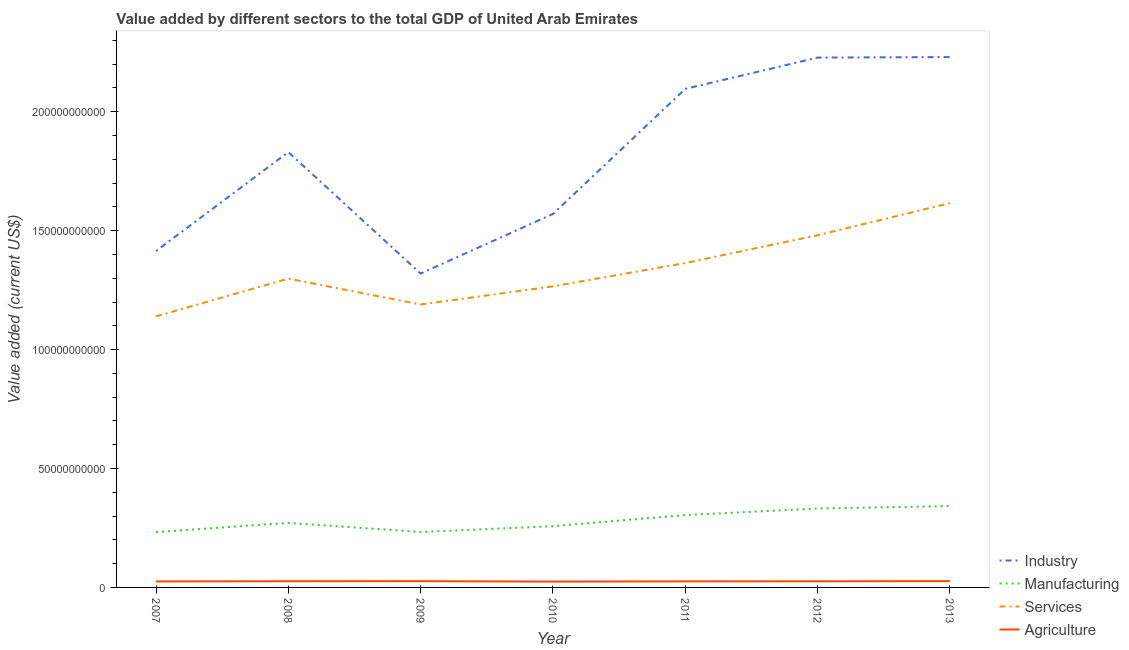Is the number of lines equal to the number of legend labels?
Give a very brief answer. Yes. What is the value added by industrial sector in 2009?
Make the answer very short. 1.32e+11. Across all years, what is the maximum value added by services sector?
Your answer should be compact. 1.62e+11. Across all years, what is the minimum value added by industrial sector?
Give a very brief answer. 1.32e+11. In which year was the value added by services sector maximum?
Ensure brevity in your answer.  2013. In which year was the value added by manufacturing sector minimum?
Your response must be concise. 2007. What is the total value added by services sector in the graph?
Offer a terse response. 9.35e+11. What is the difference between the value added by agricultural sector in 2012 and that in 2013?
Your response must be concise. -6.13e+07. What is the difference between the value added by manufacturing sector in 2009 and the value added by services sector in 2008?
Keep it short and to the point. -1.07e+11. What is the average value added by industrial sector per year?
Keep it short and to the point. 1.81e+11. In the year 2011, what is the difference between the value added by industrial sector and value added by services sector?
Provide a short and direct response. 7.32e+1. In how many years, is the value added by agricultural sector greater than 210000000000 US$?
Your answer should be very brief. 0. What is the ratio of the value added by manufacturing sector in 2010 to that in 2011?
Provide a short and direct response. 0.85. Is the value added by services sector in 2008 less than that in 2010?
Provide a short and direct response. No. Is the difference between the value added by services sector in 2009 and 2011 greater than the difference between the value added by manufacturing sector in 2009 and 2011?
Your answer should be compact. No. What is the difference between the highest and the second highest value added by agricultural sector?
Give a very brief answer. 1.44e+07. What is the difference between the highest and the lowest value added by services sector?
Make the answer very short. 4.76e+1. In how many years, is the value added by services sector greater than the average value added by services sector taken over all years?
Offer a very short reply. 3. Is it the case that in every year, the sum of the value added by industrial sector and value added by manufacturing sector is greater than the sum of value added by services sector and value added by agricultural sector?
Give a very brief answer. Yes. Is it the case that in every year, the sum of the value added by industrial sector and value added by manufacturing sector is greater than the value added by services sector?
Your answer should be compact. Yes. Does the value added by services sector monotonically increase over the years?
Offer a very short reply. No. Is the value added by agricultural sector strictly greater than the value added by services sector over the years?
Offer a very short reply. No. What is the difference between two consecutive major ticks on the Y-axis?
Give a very brief answer. 5.00e+1. Are the values on the major ticks of Y-axis written in scientific E-notation?
Make the answer very short. No. Does the graph contain any zero values?
Offer a very short reply. No. Does the graph contain grids?
Give a very brief answer. No. Where does the legend appear in the graph?
Give a very brief answer. Bottom right. What is the title of the graph?
Make the answer very short. Value added by different sectors to the total GDP of United Arab Emirates. Does "Tertiary schools" appear as one of the legend labels in the graph?
Give a very brief answer. No. What is the label or title of the X-axis?
Ensure brevity in your answer.  Year. What is the label or title of the Y-axis?
Make the answer very short. Value added (current US$). What is the Value added (current US$) of Industry in 2007?
Ensure brevity in your answer.  1.41e+11. What is the Value added (current US$) of Manufacturing in 2007?
Offer a very short reply. 2.33e+1. What is the Value added (current US$) of Services in 2007?
Give a very brief answer. 1.14e+11. What is the Value added (current US$) of Agriculture in 2007?
Provide a succinct answer. 2.52e+09. What is the Value added (current US$) in Industry in 2008?
Your answer should be very brief. 1.83e+11. What is the Value added (current US$) of Manufacturing in 2008?
Provide a succinct answer. 2.71e+1. What is the Value added (current US$) in Services in 2008?
Give a very brief answer. 1.30e+11. What is the Value added (current US$) of Agriculture in 2008?
Provide a succinct answer. 2.61e+09. What is the Value added (current US$) in Industry in 2009?
Keep it short and to the point. 1.32e+11. What is the Value added (current US$) of Manufacturing in 2009?
Provide a short and direct response. 2.33e+1. What is the Value added (current US$) in Services in 2009?
Your answer should be compact. 1.19e+11. What is the Value added (current US$) of Agriculture in 2009?
Give a very brief answer. 2.63e+09. What is the Value added (current US$) in Industry in 2010?
Offer a terse response. 1.57e+11. What is the Value added (current US$) of Manufacturing in 2010?
Offer a terse response. 2.57e+1. What is the Value added (current US$) in Services in 2010?
Your answer should be compact. 1.27e+11. What is the Value added (current US$) of Agriculture in 2010?
Keep it short and to the point. 2.45e+09. What is the Value added (current US$) of Industry in 2011?
Ensure brevity in your answer.  2.10e+11. What is the Value added (current US$) in Manufacturing in 2011?
Offer a very short reply. 3.04e+1. What is the Value added (current US$) in Services in 2011?
Keep it short and to the point. 1.36e+11. What is the Value added (current US$) in Agriculture in 2011?
Ensure brevity in your answer.  2.55e+09. What is the Value added (current US$) in Industry in 2012?
Ensure brevity in your answer.  2.23e+11. What is the Value added (current US$) of Manufacturing in 2012?
Make the answer very short. 3.32e+1. What is the Value added (current US$) in Services in 2012?
Ensure brevity in your answer.  1.48e+11. What is the Value added (current US$) of Agriculture in 2012?
Keep it short and to the point. 2.58e+09. What is the Value added (current US$) in Industry in 2013?
Keep it short and to the point. 2.23e+11. What is the Value added (current US$) of Manufacturing in 2013?
Your answer should be very brief. 3.42e+1. What is the Value added (current US$) of Services in 2013?
Provide a succinct answer. 1.62e+11. What is the Value added (current US$) in Agriculture in 2013?
Ensure brevity in your answer.  2.64e+09. Across all years, what is the maximum Value added (current US$) of Industry?
Provide a succinct answer. 2.23e+11. Across all years, what is the maximum Value added (current US$) in Manufacturing?
Ensure brevity in your answer.  3.42e+1. Across all years, what is the maximum Value added (current US$) in Services?
Give a very brief answer. 1.62e+11. Across all years, what is the maximum Value added (current US$) of Agriculture?
Your answer should be compact. 2.64e+09. Across all years, what is the minimum Value added (current US$) of Industry?
Offer a very short reply. 1.32e+11. Across all years, what is the minimum Value added (current US$) of Manufacturing?
Your answer should be compact. 2.33e+1. Across all years, what is the minimum Value added (current US$) of Services?
Your answer should be very brief. 1.14e+11. Across all years, what is the minimum Value added (current US$) in Agriculture?
Your answer should be very brief. 2.45e+09. What is the total Value added (current US$) in Industry in the graph?
Keep it short and to the point. 1.27e+12. What is the total Value added (current US$) of Manufacturing in the graph?
Provide a succinct answer. 1.97e+11. What is the total Value added (current US$) of Services in the graph?
Offer a very short reply. 9.35e+11. What is the total Value added (current US$) in Agriculture in the graph?
Keep it short and to the point. 1.80e+1. What is the difference between the Value added (current US$) of Industry in 2007 and that in 2008?
Give a very brief answer. -4.16e+1. What is the difference between the Value added (current US$) of Manufacturing in 2007 and that in 2008?
Provide a succinct answer. -3.85e+09. What is the difference between the Value added (current US$) in Services in 2007 and that in 2008?
Keep it short and to the point. -1.59e+1. What is the difference between the Value added (current US$) in Agriculture in 2007 and that in 2008?
Keep it short and to the point. -9.09e+07. What is the difference between the Value added (current US$) of Industry in 2007 and that in 2009?
Make the answer very short. 9.48e+09. What is the difference between the Value added (current US$) of Manufacturing in 2007 and that in 2009?
Give a very brief answer. -3.62e+07. What is the difference between the Value added (current US$) of Services in 2007 and that in 2009?
Give a very brief answer. -5.00e+09. What is the difference between the Value added (current US$) of Agriculture in 2007 and that in 2009?
Ensure brevity in your answer.  -1.10e+08. What is the difference between the Value added (current US$) in Industry in 2007 and that in 2010?
Your answer should be very brief. -1.56e+1. What is the difference between the Value added (current US$) of Manufacturing in 2007 and that in 2010?
Keep it short and to the point. -2.47e+09. What is the difference between the Value added (current US$) of Services in 2007 and that in 2010?
Your response must be concise. -1.26e+1. What is the difference between the Value added (current US$) of Agriculture in 2007 and that in 2010?
Your answer should be compact. 7.05e+07. What is the difference between the Value added (current US$) in Industry in 2007 and that in 2011?
Offer a very short reply. -6.82e+1. What is the difference between the Value added (current US$) of Manufacturing in 2007 and that in 2011?
Offer a terse response. -7.16e+09. What is the difference between the Value added (current US$) in Services in 2007 and that in 2011?
Make the answer very short. -2.24e+1. What is the difference between the Value added (current US$) of Agriculture in 2007 and that in 2011?
Your answer should be very brief. -2.80e+07. What is the difference between the Value added (current US$) in Industry in 2007 and that in 2012?
Offer a very short reply. -8.13e+1. What is the difference between the Value added (current US$) in Manufacturing in 2007 and that in 2012?
Keep it short and to the point. -9.89e+09. What is the difference between the Value added (current US$) of Services in 2007 and that in 2012?
Ensure brevity in your answer.  -3.41e+1. What is the difference between the Value added (current US$) in Agriculture in 2007 and that in 2012?
Offer a terse response. -6.32e+07. What is the difference between the Value added (current US$) of Industry in 2007 and that in 2013?
Give a very brief answer. -8.16e+1. What is the difference between the Value added (current US$) in Manufacturing in 2007 and that in 2013?
Offer a terse response. -1.09e+1. What is the difference between the Value added (current US$) in Services in 2007 and that in 2013?
Provide a succinct answer. -4.76e+1. What is the difference between the Value added (current US$) in Agriculture in 2007 and that in 2013?
Keep it short and to the point. -1.24e+08. What is the difference between the Value added (current US$) in Industry in 2008 and that in 2009?
Your answer should be very brief. 5.11e+1. What is the difference between the Value added (current US$) in Manufacturing in 2008 and that in 2009?
Offer a terse response. 3.82e+09. What is the difference between the Value added (current US$) in Services in 2008 and that in 2009?
Make the answer very short. 1.09e+1. What is the difference between the Value added (current US$) of Agriculture in 2008 and that in 2009?
Offer a very short reply. -1.91e+07. What is the difference between the Value added (current US$) of Industry in 2008 and that in 2010?
Keep it short and to the point. 2.60e+1. What is the difference between the Value added (current US$) in Manufacturing in 2008 and that in 2010?
Provide a succinct answer. 1.39e+09. What is the difference between the Value added (current US$) in Services in 2008 and that in 2010?
Offer a terse response. 3.25e+09. What is the difference between the Value added (current US$) in Agriculture in 2008 and that in 2010?
Your answer should be compact. 1.61e+08. What is the difference between the Value added (current US$) of Industry in 2008 and that in 2011?
Your response must be concise. -2.66e+1. What is the difference between the Value added (current US$) in Manufacturing in 2008 and that in 2011?
Give a very brief answer. -3.30e+09. What is the difference between the Value added (current US$) in Services in 2008 and that in 2011?
Your answer should be very brief. -6.54e+09. What is the difference between the Value added (current US$) of Agriculture in 2008 and that in 2011?
Provide a succinct answer. 6.29e+07. What is the difference between the Value added (current US$) in Industry in 2008 and that in 2012?
Provide a succinct answer. -3.97e+1. What is the difference between the Value added (current US$) in Manufacturing in 2008 and that in 2012?
Offer a terse response. -6.04e+09. What is the difference between the Value added (current US$) of Services in 2008 and that in 2012?
Ensure brevity in your answer.  -1.82e+1. What is the difference between the Value added (current US$) in Agriculture in 2008 and that in 2012?
Provide a short and direct response. 2.78e+07. What is the difference between the Value added (current US$) in Industry in 2008 and that in 2013?
Offer a very short reply. -4.00e+1. What is the difference between the Value added (current US$) in Manufacturing in 2008 and that in 2013?
Provide a short and direct response. -7.08e+09. What is the difference between the Value added (current US$) of Services in 2008 and that in 2013?
Ensure brevity in your answer.  -3.17e+1. What is the difference between the Value added (current US$) of Agriculture in 2008 and that in 2013?
Your response must be concise. -3.35e+07. What is the difference between the Value added (current US$) of Industry in 2009 and that in 2010?
Provide a succinct answer. -2.51e+1. What is the difference between the Value added (current US$) in Manufacturing in 2009 and that in 2010?
Make the answer very short. -2.43e+09. What is the difference between the Value added (current US$) in Services in 2009 and that in 2010?
Offer a terse response. -7.62e+09. What is the difference between the Value added (current US$) in Agriculture in 2009 and that in 2010?
Your answer should be compact. 1.81e+08. What is the difference between the Value added (current US$) in Industry in 2009 and that in 2011?
Give a very brief answer. -7.76e+1. What is the difference between the Value added (current US$) of Manufacturing in 2009 and that in 2011?
Offer a terse response. -7.12e+09. What is the difference between the Value added (current US$) in Services in 2009 and that in 2011?
Offer a very short reply. -1.74e+1. What is the difference between the Value added (current US$) in Agriculture in 2009 and that in 2011?
Make the answer very short. 8.20e+07. What is the difference between the Value added (current US$) of Industry in 2009 and that in 2012?
Offer a terse response. -9.08e+1. What is the difference between the Value added (current US$) in Manufacturing in 2009 and that in 2012?
Provide a succinct answer. -9.86e+09. What is the difference between the Value added (current US$) of Services in 2009 and that in 2012?
Provide a short and direct response. -2.91e+1. What is the difference between the Value added (current US$) of Agriculture in 2009 and that in 2012?
Offer a terse response. 4.68e+07. What is the difference between the Value added (current US$) of Industry in 2009 and that in 2013?
Your answer should be very brief. -9.10e+1. What is the difference between the Value added (current US$) in Manufacturing in 2009 and that in 2013?
Provide a short and direct response. -1.09e+1. What is the difference between the Value added (current US$) in Services in 2009 and that in 2013?
Keep it short and to the point. -4.26e+1. What is the difference between the Value added (current US$) in Agriculture in 2009 and that in 2013?
Offer a very short reply. -1.44e+07. What is the difference between the Value added (current US$) in Industry in 2010 and that in 2011?
Offer a very short reply. -5.26e+1. What is the difference between the Value added (current US$) in Manufacturing in 2010 and that in 2011?
Your answer should be very brief. -4.69e+09. What is the difference between the Value added (current US$) of Services in 2010 and that in 2011?
Offer a very short reply. -9.79e+09. What is the difference between the Value added (current US$) in Agriculture in 2010 and that in 2011?
Offer a very short reply. -9.86e+07. What is the difference between the Value added (current US$) of Industry in 2010 and that in 2012?
Your answer should be very brief. -6.57e+1. What is the difference between the Value added (current US$) of Manufacturing in 2010 and that in 2012?
Provide a succinct answer. -7.43e+09. What is the difference between the Value added (current US$) in Services in 2010 and that in 2012?
Make the answer very short. -2.15e+1. What is the difference between the Value added (current US$) of Agriculture in 2010 and that in 2012?
Make the answer very short. -1.34e+08. What is the difference between the Value added (current US$) of Industry in 2010 and that in 2013?
Your answer should be compact. -6.60e+1. What is the difference between the Value added (current US$) of Manufacturing in 2010 and that in 2013?
Offer a very short reply. -8.46e+09. What is the difference between the Value added (current US$) in Services in 2010 and that in 2013?
Provide a short and direct response. -3.50e+1. What is the difference between the Value added (current US$) in Agriculture in 2010 and that in 2013?
Provide a succinct answer. -1.95e+08. What is the difference between the Value added (current US$) in Industry in 2011 and that in 2012?
Provide a succinct answer. -1.32e+1. What is the difference between the Value added (current US$) of Manufacturing in 2011 and that in 2012?
Your answer should be compact. -2.73e+09. What is the difference between the Value added (current US$) of Services in 2011 and that in 2012?
Your answer should be compact. -1.17e+1. What is the difference between the Value added (current US$) of Agriculture in 2011 and that in 2012?
Offer a terse response. -3.51e+07. What is the difference between the Value added (current US$) in Industry in 2011 and that in 2013?
Your answer should be compact. -1.34e+1. What is the difference between the Value added (current US$) of Manufacturing in 2011 and that in 2013?
Ensure brevity in your answer.  -3.77e+09. What is the difference between the Value added (current US$) in Services in 2011 and that in 2013?
Offer a terse response. -2.52e+1. What is the difference between the Value added (current US$) of Agriculture in 2011 and that in 2013?
Provide a succinct answer. -9.64e+07. What is the difference between the Value added (current US$) of Industry in 2012 and that in 2013?
Provide a succinct answer. -2.27e+08. What is the difference between the Value added (current US$) in Manufacturing in 2012 and that in 2013?
Your response must be concise. -1.04e+09. What is the difference between the Value added (current US$) of Services in 2012 and that in 2013?
Ensure brevity in your answer.  -1.35e+1. What is the difference between the Value added (current US$) of Agriculture in 2012 and that in 2013?
Keep it short and to the point. -6.13e+07. What is the difference between the Value added (current US$) in Industry in 2007 and the Value added (current US$) in Manufacturing in 2008?
Offer a very short reply. 1.14e+11. What is the difference between the Value added (current US$) in Industry in 2007 and the Value added (current US$) in Services in 2008?
Your response must be concise. 1.16e+1. What is the difference between the Value added (current US$) in Industry in 2007 and the Value added (current US$) in Agriculture in 2008?
Provide a short and direct response. 1.39e+11. What is the difference between the Value added (current US$) of Manufacturing in 2007 and the Value added (current US$) of Services in 2008?
Keep it short and to the point. -1.07e+11. What is the difference between the Value added (current US$) in Manufacturing in 2007 and the Value added (current US$) in Agriculture in 2008?
Your answer should be compact. 2.07e+1. What is the difference between the Value added (current US$) of Services in 2007 and the Value added (current US$) of Agriculture in 2008?
Keep it short and to the point. 1.11e+11. What is the difference between the Value added (current US$) of Industry in 2007 and the Value added (current US$) of Manufacturing in 2009?
Ensure brevity in your answer.  1.18e+11. What is the difference between the Value added (current US$) in Industry in 2007 and the Value added (current US$) in Services in 2009?
Provide a succinct answer. 2.25e+1. What is the difference between the Value added (current US$) in Industry in 2007 and the Value added (current US$) in Agriculture in 2009?
Make the answer very short. 1.39e+11. What is the difference between the Value added (current US$) in Manufacturing in 2007 and the Value added (current US$) in Services in 2009?
Offer a very short reply. -9.57e+1. What is the difference between the Value added (current US$) in Manufacturing in 2007 and the Value added (current US$) in Agriculture in 2009?
Your response must be concise. 2.06e+1. What is the difference between the Value added (current US$) in Services in 2007 and the Value added (current US$) in Agriculture in 2009?
Provide a succinct answer. 1.11e+11. What is the difference between the Value added (current US$) of Industry in 2007 and the Value added (current US$) of Manufacturing in 2010?
Your answer should be compact. 1.16e+11. What is the difference between the Value added (current US$) of Industry in 2007 and the Value added (current US$) of Services in 2010?
Keep it short and to the point. 1.49e+1. What is the difference between the Value added (current US$) of Industry in 2007 and the Value added (current US$) of Agriculture in 2010?
Make the answer very short. 1.39e+11. What is the difference between the Value added (current US$) of Manufacturing in 2007 and the Value added (current US$) of Services in 2010?
Keep it short and to the point. -1.03e+11. What is the difference between the Value added (current US$) in Manufacturing in 2007 and the Value added (current US$) in Agriculture in 2010?
Offer a terse response. 2.08e+1. What is the difference between the Value added (current US$) in Services in 2007 and the Value added (current US$) in Agriculture in 2010?
Keep it short and to the point. 1.12e+11. What is the difference between the Value added (current US$) in Industry in 2007 and the Value added (current US$) in Manufacturing in 2011?
Keep it short and to the point. 1.11e+11. What is the difference between the Value added (current US$) in Industry in 2007 and the Value added (current US$) in Services in 2011?
Make the answer very short. 5.06e+09. What is the difference between the Value added (current US$) in Industry in 2007 and the Value added (current US$) in Agriculture in 2011?
Offer a terse response. 1.39e+11. What is the difference between the Value added (current US$) in Manufacturing in 2007 and the Value added (current US$) in Services in 2011?
Your answer should be very brief. -1.13e+11. What is the difference between the Value added (current US$) in Manufacturing in 2007 and the Value added (current US$) in Agriculture in 2011?
Offer a very short reply. 2.07e+1. What is the difference between the Value added (current US$) of Services in 2007 and the Value added (current US$) of Agriculture in 2011?
Give a very brief answer. 1.11e+11. What is the difference between the Value added (current US$) of Industry in 2007 and the Value added (current US$) of Manufacturing in 2012?
Give a very brief answer. 1.08e+11. What is the difference between the Value added (current US$) in Industry in 2007 and the Value added (current US$) in Services in 2012?
Offer a terse response. -6.64e+09. What is the difference between the Value added (current US$) in Industry in 2007 and the Value added (current US$) in Agriculture in 2012?
Make the answer very short. 1.39e+11. What is the difference between the Value added (current US$) of Manufacturing in 2007 and the Value added (current US$) of Services in 2012?
Offer a very short reply. -1.25e+11. What is the difference between the Value added (current US$) of Manufacturing in 2007 and the Value added (current US$) of Agriculture in 2012?
Offer a terse response. 2.07e+1. What is the difference between the Value added (current US$) in Services in 2007 and the Value added (current US$) in Agriculture in 2012?
Offer a terse response. 1.11e+11. What is the difference between the Value added (current US$) of Industry in 2007 and the Value added (current US$) of Manufacturing in 2013?
Your response must be concise. 1.07e+11. What is the difference between the Value added (current US$) in Industry in 2007 and the Value added (current US$) in Services in 2013?
Your response must be concise. -2.01e+1. What is the difference between the Value added (current US$) of Industry in 2007 and the Value added (current US$) of Agriculture in 2013?
Ensure brevity in your answer.  1.39e+11. What is the difference between the Value added (current US$) in Manufacturing in 2007 and the Value added (current US$) in Services in 2013?
Your answer should be compact. -1.38e+11. What is the difference between the Value added (current US$) in Manufacturing in 2007 and the Value added (current US$) in Agriculture in 2013?
Offer a very short reply. 2.06e+1. What is the difference between the Value added (current US$) of Services in 2007 and the Value added (current US$) of Agriculture in 2013?
Offer a terse response. 1.11e+11. What is the difference between the Value added (current US$) in Industry in 2008 and the Value added (current US$) in Manufacturing in 2009?
Offer a very short reply. 1.60e+11. What is the difference between the Value added (current US$) of Industry in 2008 and the Value added (current US$) of Services in 2009?
Your response must be concise. 6.41e+1. What is the difference between the Value added (current US$) of Industry in 2008 and the Value added (current US$) of Agriculture in 2009?
Make the answer very short. 1.80e+11. What is the difference between the Value added (current US$) in Manufacturing in 2008 and the Value added (current US$) in Services in 2009?
Provide a short and direct response. -9.18e+1. What is the difference between the Value added (current US$) in Manufacturing in 2008 and the Value added (current US$) in Agriculture in 2009?
Provide a short and direct response. 2.45e+1. What is the difference between the Value added (current US$) of Services in 2008 and the Value added (current US$) of Agriculture in 2009?
Your answer should be very brief. 1.27e+11. What is the difference between the Value added (current US$) of Industry in 2008 and the Value added (current US$) of Manufacturing in 2010?
Make the answer very short. 1.57e+11. What is the difference between the Value added (current US$) in Industry in 2008 and the Value added (current US$) in Services in 2010?
Your response must be concise. 5.64e+1. What is the difference between the Value added (current US$) in Industry in 2008 and the Value added (current US$) in Agriculture in 2010?
Give a very brief answer. 1.81e+11. What is the difference between the Value added (current US$) in Manufacturing in 2008 and the Value added (current US$) in Services in 2010?
Keep it short and to the point. -9.95e+1. What is the difference between the Value added (current US$) in Manufacturing in 2008 and the Value added (current US$) in Agriculture in 2010?
Make the answer very short. 2.47e+1. What is the difference between the Value added (current US$) in Services in 2008 and the Value added (current US$) in Agriculture in 2010?
Keep it short and to the point. 1.27e+11. What is the difference between the Value added (current US$) in Industry in 2008 and the Value added (current US$) in Manufacturing in 2011?
Provide a short and direct response. 1.53e+11. What is the difference between the Value added (current US$) in Industry in 2008 and the Value added (current US$) in Services in 2011?
Provide a short and direct response. 4.67e+1. What is the difference between the Value added (current US$) in Industry in 2008 and the Value added (current US$) in Agriculture in 2011?
Make the answer very short. 1.80e+11. What is the difference between the Value added (current US$) in Manufacturing in 2008 and the Value added (current US$) in Services in 2011?
Offer a very short reply. -1.09e+11. What is the difference between the Value added (current US$) of Manufacturing in 2008 and the Value added (current US$) of Agriculture in 2011?
Make the answer very short. 2.46e+1. What is the difference between the Value added (current US$) of Services in 2008 and the Value added (current US$) of Agriculture in 2011?
Provide a succinct answer. 1.27e+11. What is the difference between the Value added (current US$) of Industry in 2008 and the Value added (current US$) of Manufacturing in 2012?
Your answer should be very brief. 1.50e+11. What is the difference between the Value added (current US$) in Industry in 2008 and the Value added (current US$) in Services in 2012?
Offer a very short reply. 3.50e+1. What is the difference between the Value added (current US$) in Industry in 2008 and the Value added (current US$) in Agriculture in 2012?
Your answer should be very brief. 1.80e+11. What is the difference between the Value added (current US$) of Manufacturing in 2008 and the Value added (current US$) of Services in 2012?
Your response must be concise. -1.21e+11. What is the difference between the Value added (current US$) of Manufacturing in 2008 and the Value added (current US$) of Agriculture in 2012?
Ensure brevity in your answer.  2.45e+1. What is the difference between the Value added (current US$) in Services in 2008 and the Value added (current US$) in Agriculture in 2012?
Keep it short and to the point. 1.27e+11. What is the difference between the Value added (current US$) in Industry in 2008 and the Value added (current US$) in Manufacturing in 2013?
Provide a succinct answer. 1.49e+11. What is the difference between the Value added (current US$) in Industry in 2008 and the Value added (current US$) in Services in 2013?
Your response must be concise. 2.15e+1. What is the difference between the Value added (current US$) of Industry in 2008 and the Value added (current US$) of Agriculture in 2013?
Keep it short and to the point. 1.80e+11. What is the difference between the Value added (current US$) in Manufacturing in 2008 and the Value added (current US$) in Services in 2013?
Your answer should be compact. -1.34e+11. What is the difference between the Value added (current US$) in Manufacturing in 2008 and the Value added (current US$) in Agriculture in 2013?
Your response must be concise. 2.45e+1. What is the difference between the Value added (current US$) of Services in 2008 and the Value added (current US$) of Agriculture in 2013?
Provide a succinct answer. 1.27e+11. What is the difference between the Value added (current US$) of Industry in 2009 and the Value added (current US$) of Manufacturing in 2010?
Your answer should be very brief. 1.06e+11. What is the difference between the Value added (current US$) in Industry in 2009 and the Value added (current US$) in Services in 2010?
Keep it short and to the point. 5.38e+09. What is the difference between the Value added (current US$) of Industry in 2009 and the Value added (current US$) of Agriculture in 2010?
Keep it short and to the point. 1.30e+11. What is the difference between the Value added (current US$) in Manufacturing in 2009 and the Value added (current US$) in Services in 2010?
Make the answer very short. -1.03e+11. What is the difference between the Value added (current US$) of Manufacturing in 2009 and the Value added (current US$) of Agriculture in 2010?
Give a very brief answer. 2.09e+1. What is the difference between the Value added (current US$) of Services in 2009 and the Value added (current US$) of Agriculture in 2010?
Give a very brief answer. 1.17e+11. What is the difference between the Value added (current US$) in Industry in 2009 and the Value added (current US$) in Manufacturing in 2011?
Provide a short and direct response. 1.02e+11. What is the difference between the Value added (current US$) in Industry in 2009 and the Value added (current US$) in Services in 2011?
Offer a terse response. -4.42e+09. What is the difference between the Value added (current US$) in Industry in 2009 and the Value added (current US$) in Agriculture in 2011?
Ensure brevity in your answer.  1.29e+11. What is the difference between the Value added (current US$) of Manufacturing in 2009 and the Value added (current US$) of Services in 2011?
Keep it short and to the point. -1.13e+11. What is the difference between the Value added (current US$) of Manufacturing in 2009 and the Value added (current US$) of Agriculture in 2011?
Your answer should be compact. 2.08e+1. What is the difference between the Value added (current US$) of Services in 2009 and the Value added (current US$) of Agriculture in 2011?
Your response must be concise. 1.16e+11. What is the difference between the Value added (current US$) of Industry in 2009 and the Value added (current US$) of Manufacturing in 2012?
Your answer should be very brief. 9.88e+1. What is the difference between the Value added (current US$) of Industry in 2009 and the Value added (current US$) of Services in 2012?
Offer a terse response. -1.61e+1. What is the difference between the Value added (current US$) in Industry in 2009 and the Value added (current US$) in Agriculture in 2012?
Offer a very short reply. 1.29e+11. What is the difference between the Value added (current US$) of Manufacturing in 2009 and the Value added (current US$) of Services in 2012?
Ensure brevity in your answer.  -1.25e+11. What is the difference between the Value added (current US$) in Manufacturing in 2009 and the Value added (current US$) in Agriculture in 2012?
Offer a very short reply. 2.07e+1. What is the difference between the Value added (current US$) in Services in 2009 and the Value added (current US$) in Agriculture in 2012?
Your answer should be very brief. 1.16e+11. What is the difference between the Value added (current US$) in Industry in 2009 and the Value added (current US$) in Manufacturing in 2013?
Keep it short and to the point. 9.78e+1. What is the difference between the Value added (current US$) in Industry in 2009 and the Value added (current US$) in Services in 2013?
Your response must be concise. -2.96e+1. What is the difference between the Value added (current US$) in Industry in 2009 and the Value added (current US$) in Agriculture in 2013?
Offer a terse response. 1.29e+11. What is the difference between the Value added (current US$) in Manufacturing in 2009 and the Value added (current US$) in Services in 2013?
Keep it short and to the point. -1.38e+11. What is the difference between the Value added (current US$) in Manufacturing in 2009 and the Value added (current US$) in Agriculture in 2013?
Provide a short and direct response. 2.07e+1. What is the difference between the Value added (current US$) of Services in 2009 and the Value added (current US$) of Agriculture in 2013?
Your response must be concise. 1.16e+11. What is the difference between the Value added (current US$) in Industry in 2010 and the Value added (current US$) in Manufacturing in 2011?
Provide a succinct answer. 1.27e+11. What is the difference between the Value added (current US$) of Industry in 2010 and the Value added (current US$) of Services in 2011?
Offer a very short reply. 2.06e+1. What is the difference between the Value added (current US$) of Industry in 2010 and the Value added (current US$) of Agriculture in 2011?
Make the answer very short. 1.54e+11. What is the difference between the Value added (current US$) in Manufacturing in 2010 and the Value added (current US$) in Services in 2011?
Offer a very short reply. -1.11e+11. What is the difference between the Value added (current US$) in Manufacturing in 2010 and the Value added (current US$) in Agriculture in 2011?
Offer a terse response. 2.32e+1. What is the difference between the Value added (current US$) in Services in 2010 and the Value added (current US$) in Agriculture in 2011?
Offer a very short reply. 1.24e+11. What is the difference between the Value added (current US$) of Industry in 2010 and the Value added (current US$) of Manufacturing in 2012?
Provide a succinct answer. 1.24e+11. What is the difference between the Value added (current US$) of Industry in 2010 and the Value added (current US$) of Services in 2012?
Your answer should be compact. 8.94e+09. What is the difference between the Value added (current US$) in Industry in 2010 and the Value added (current US$) in Agriculture in 2012?
Make the answer very short. 1.54e+11. What is the difference between the Value added (current US$) in Manufacturing in 2010 and the Value added (current US$) in Services in 2012?
Your answer should be very brief. -1.22e+11. What is the difference between the Value added (current US$) in Manufacturing in 2010 and the Value added (current US$) in Agriculture in 2012?
Your response must be concise. 2.32e+1. What is the difference between the Value added (current US$) in Services in 2010 and the Value added (current US$) in Agriculture in 2012?
Offer a terse response. 1.24e+11. What is the difference between the Value added (current US$) in Industry in 2010 and the Value added (current US$) in Manufacturing in 2013?
Your answer should be very brief. 1.23e+11. What is the difference between the Value added (current US$) of Industry in 2010 and the Value added (current US$) of Services in 2013?
Offer a terse response. -4.54e+09. What is the difference between the Value added (current US$) of Industry in 2010 and the Value added (current US$) of Agriculture in 2013?
Offer a very short reply. 1.54e+11. What is the difference between the Value added (current US$) in Manufacturing in 2010 and the Value added (current US$) in Services in 2013?
Give a very brief answer. -1.36e+11. What is the difference between the Value added (current US$) of Manufacturing in 2010 and the Value added (current US$) of Agriculture in 2013?
Offer a very short reply. 2.31e+1. What is the difference between the Value added (current US$) in Services in 2010 and the Value added (current US$) in Agriculture in 2013?
Your answer should be compact. 1.24e+11. What is the difference between the Value added (current US$) in Industry in 2011 and the Value added (current US$) in Manufacturing in 2012?
Provide a succinct answer. 1.76e+11. What is the difference between the Value added (current US$) of Industry in 2011 and the Value added (current US$) of Services in 2012?
Your answer should be compact. 6.15e+1. What is the difference between the Value added (current US$) of Industry in 2011 and the Value added (current US$) of Agriculture in 2012?
Your answer should be compact. 2.07e+11. What is the difference between the Value added (current US$) of Manufacturing in 2011 and the Value added (current US$) of Services in 2012?
Give a very brief answer. -1.18e+11. What is the difference between the Value added (current US$) of Manufacturing in 2011 and the Value added (current US$) of Agriculture in 2012?
Ensure brevity in your answer.  2.79e+1. What is the difference between the Value added (current US$) in Services in 2011 and the Value added (current US$) in Agriculture in 2012?
Offer a terse response. 1.34e+11. What is the difference between the Value added (current US$) of Industry in 2011 and the Value added (current US$) of Manufacturing in 2013?
Offer a terse response. 1.75e+11. What is the difference between the Value added (current US$) in Industry in 2011 and the Value added (current US$) in Services in 2013?
Offer a terse response. 4.80e+1. What is the difference between the Value added (current US$) of Industry in 2011 and the Value added (current US$) of Agriculture in 2013?
Offer a terse response. 2.07e+11. What is the difference between the Value added (current US$) in Manufacturing in 2011 and the Value added (current US$) in Services in 2013?
Offer a terse response. -1.31e+11. What is the difference between the Value added (current US$) in Manufacturing in 2011 and the Value added (current US$) in Agriculture in 2013?
Make the answer very short. 2.78e+1. What is the difference between the Value added (current US$) of Services in 2011 and the Value added (current US$) of Agriculture in 2013?
Your answer should be very brief. 1.34e+11. What is the difference between the Value added (current US$) in Industry in 2012 and the Value added (current US$) in Manufacturing in 2013?
Your answer should be compact. 1.89e+11. What is the difference between the Value added (current US$) of Industry in 2012 and the Value added (current US$) of Services in 2013?
Ensure brevity in your answer.  6.12e+1. What is the difference between the Value added (current US$) in Industry in 2012 and the Value added (current US$) in Agriculture in 2013?
Give a very brief answer. 2.20e+11. What is the difference between the Value added (current US$) of Manufacturing in 2012 and the Value added (current US$) of Services in 2013?
Give a very brief answer. -1.28e+11. What is the difference between the Value added (current US$) of Manufacturing in 2012 and the Value added (current US$) of Agriculture in 2013?
Ensure brevity in your answer.  3.05e+1. What is the difference between the Value added (current US$) in Services in 2012 and the Value added (current US$) in Agriculture in 2013?
Your answer should be very brief. 1.45e+11. What is the average Value added (current US$) in Industry per year?
Provide a succinct answer. 1.81e+11. What is the average Value added (current US$) in Manufacturing per year?
Give a very brief answer. 2.82e+1. What is the average Value added (current US$) in Services per year?
Offer a terse response. 1.34e+11. What is the average Value added (current US$) in Agriculture per year?
Provide a succinct answer. 2.57e+09. In the year 2007, what is the difference between the Value added (current US$) in Industry and Value added (current US$) in Manufacturing?
Give a very brief answer. 1.18e+11. In the year 2007, what is the difference between the Value added (current US$) in Industry and Value added (current US$) in Services?
Your answer should be very brief. 2.75e+1. In the year 2007, what is the difference between the Value added (current US$) of Industry and Value added (current US$) of Agriculture?
Provide a succinct answer. 1.39e+11. In the year 2007, what is the difference between the Value added (current US$) of Manufacturing and Value added (current US$) of Services?
Offer a very short reply. -9.07e+1. In the year 2007, what is the difference between the Value added (current US$) of Manufacturing and Value added (current US$) of Agriculture?
Provide a succinct answer. 2.08e+1. In the year 2007, what is the difference between the Value added (current US$) in Services and Value added (current US$) in Agriculture?
Your answer should be very brief. 1.11e+11. In the year 2008, what is the difference between the Value added (current US$) of Industry and Value added (current US$) of Manufacturing?
Your answer should be compact. 1.56e+11. In the year 2008, what is the difference between the Value added (current US$) of Industry and Value added (current US$) of Services?
Ensure brevity in your answer.  5.32e+1. In the year 2008, what is the difference between the Value added (current US$) in Industry and Value added (current US$) in Agriculture?
Provide a succinct answer. 1.80e+11. In the year 2008, what is the difference between the Value added (current US$) in Manufacturing and Value added (current US$) in Services?
Make the answer very short. -1.03e+11. In the year 2008, what is the difference between the Value added (current US$) of Manufacturing and Value added (current US$) of Agriculture?
Provide a short and direct response. 2.45e+1. In the year 2008, what is the difference between the Value added (current US$) of Services and Value added (current US$) of Agriculture?
Your answer should be very brief. 1.27e+11. In the year 2009, what is the difference between the Value added (current US$) in Industry and Value added (current US$) in Manufacturing?
Provide a short and direct response. 1.09e+11. In the year 2009, what is the difference between the Value added (current US$) of Industry and Value added (current US$) of Services?
Give a very brief answer. 1.30e+1. In the year 2009, what is the difference between the Value added (current US$) of Industry and Value added (current US$) of Agriculture?
Ensure brevity in your answer.  1.29e+11. In the year 2009, what is the difference between the Value added (current US$) of Manufacturing and Value added (current US$) of Services?
Your response must be concise. -9.56e+1. In the year 2009, what is the difference between the Value added (current US$) of Manufacturing and Value added (current US$) of Agriculture?
Offer a terse response. 2.07e+1. In the year 2009, what is the difference between the Value added (current US$) of Services and Value added (current US$) of Agriculture?
Your response must be concise. 1.16e+11. In the year 2010, what is the difference between the Value added (current US$) of Industry and Value added (current US$) of Manufacturing?
Offer a very short reply. 1.31e+11. In the year 2010, what is the difference between the Value added (current US$) of Industry and Value added (current US$) of Services?
Make the answer very short. 3.04e+1. In the year 2010, what is the difference between the Value added (current US$) in Industry and Value added (current US$) in Agriculture?
Give a very brief answer. 1.55e+11. In the year 2010, what is the difference between the Value added (current US$) of Manufacturing and Value added (current US$) of Services?
Provide a short and direct response. -1.01e+11. In the year 2010, what is the difference between the Value added (current US$) in Manufacturing and Value added (current US$) in Agriculture?
Give a very brief answer. 2.33e+1. In the year 2010, what is the difference between the Value added (current US$) of Services and Value added (current US$) of Agriculture?
Your response must be concise. 1.24e+11. In the year 2011, what is the difference between the Value added (current US$) of Industry and Value added (current US$) of Manufacturing?
Make the answer very short. 1.79e+11. In the year 2011, what is the difference between the Value added (current US$) in Industry and Value added (current US$) in Services?
Ensure brevity in your answer.  7.32e+1. In the year 2011, what is the difference between the Value added (current US$) of Industry and Value added (current US$) of Agriculture?
Offer a very short reply. 2.07e+11. In the year 2011, what is the difference between the Value added (current US$) of Manufacturing and Value added (current US$) of Services?
Provide a succinct answer. -1.06e+11. In the year 2011, what is the difference between the Value added (current US$) of Manufacturing and Value added (current US$) of Agriculture?
Make the answer very short. 2.79e+1. In the year 2011, what is the difference between the Value added (current US$) of Services and Value added (current US$) of Agriculture?
Your answer should be very brief. 1.34e+11. In the year 2012, what is the difference between the Value added (current US$) of Industry and Value added (current US$) of Manufacturing?
Your answer should be very brief. 1.90e+11. In the year 2012, what is the difference between the Value added (current US$) in Industry and Value added (current US$) in Services?
Your answer should be compact. 7.47e+1. In the year 2012, what is the difference between the Value added (current US$) of Industry and Value added (current US$) of Agriculture?
Provide a short and direct response. 2.20e+11. In the year 2012, what is the difference between the Value added (current US$) of Manufacturing and Value added (current US$) of Services?
Your answer should be very brief. -1.15e+11. In the year 2012, what is the difference between the Value added (current US$) of Manufacturing and Value added (current US$) of Agriculture?
Your response must be concise. 3.06e+1. In the year 2012, what is the difference between the Value added (current US$) in Services and Value added (current US$) in Agriculture?
Offer a very short reply. 1.45e+11. In the year 2013, what is the difference between the Value added (current US$) of Industry and Value added (current US$) of Manufacturing?
Make the answer very short. 1.89e+11. In the year 2013, what is the difference between the Value added (current US$) in Industry and Value added (current US$) in Services?
Your response must be concise. 6.14e+1. In the year 2013, what is the difference between the Value added (current US$) of Industry and Value added (current US$) of Agriculture?
Give a very brief answer. 2.20e+11. In the year 2013, what is the difference between the Value added (current US$) in Manufacturing and Value added (current US$) in Services?
Your answer should be compact. -1.27e+11. In the year 2013, what is the difference between the Value added (current US$) of Manufacturing and Value added (current US$) of Agriculture?
Ensure brevity in your answer.  3.16e+1. In the year 2013, what is the difference between the Value added (current US$) of Services and Value added (current US$) of Agriculture?
Make the answer very short. 1.59e+11. What is the ratio of the Value added (current US$) of Industry in 2007 to that in 2008?
Your response must be concise. 0.77. What is the ratio of the Value added (current US$) of Manufacturing in 2007 to that in 2008?
Provide a succinct answer. 0.86. What is the ratio of the Value added (current US$) of Services in 2007 to that in 2008?
Offer a terse response. 0.88. What is the ratio of the Value added (current US$) of Agriculture in 2007 to that in 2008?
Your answer should be very brief. 0.97. What is the ratio of the Value added (current US$) in Industry in 2007 to that in 2009?
Your answer should be compact. 1.07. What is the ratio of the Value added (current US$) of Services in 2007 to that in 2009?
Offer a very short reply. 0.96. What is the ratio of the Value added (current US$) in Agriculture in 2007 to that in 2009?
Provide a short and direct response. 0.96. What is the ratio of the Value added (current US$) of Industry in 2007 to that in 2010?
Provide a succinct answer. 0.9. What is the ratio of the Value added (current US$) in Manufacturing in 2007 to that in 2010?
Your answer should be compact. 0.9. What is the ratio of the Value added (current US$) in Services in 2007 to that in 2010?
Ensure brevity in your answer.  0.9. What is the ratio of the Value added (current US$) of Agriculture in 2007 to that in 2010?
Your answer should be compact. 1.03. What is the ratio of the Value added (current US$) in Industry in 2007 to that in 2011?
Make the answer very short. 0.67. What is the ratio of the Value added (current US$) in Manufacturing in 2007 to that in 2011?
Your answer should be very brief. 0.76. What is the ratio of the Value added (current US$) of Services in 2007 to that in 2011?
Provide a short and direct response. 0.84. What is the ratio of the Value added (current US$) of Industry in 2007 to that in 2012?
Your answer should be compact. 0.63. What is the ratio of the Value added (current US$) of Manufacturing in 2007 to that in 2012?
Keep it short and to the point. 0.7. What is the ratio of the Value added (current US$) of Services in 2007 to that in 2012?
Make the answer very short. 0.77. What is the ratio of the Value added (current US$) of Agriculture in 2007 to that in 2012?
Ensure brevity in your answer.  0.98. What is the ratio of the Value added (current US$) of Industry in 2007 to that in 2013?
Your response must be concise. 0.63. What is the ratio of the Value added (current US$) of Manufacturing in 2007 to that in 2013?
Provide a short and direct response. 0.68. What is the ratio of the Value added (current US$) of Services in 2007 to that in 2013?
Offer a terse response. 0.71. What is the ratio of the Value added (current US$) of Agriculture in 2007 to that in 2013?
Keep it short and to the point. 0.95. What is the ratio of the Value added (current US$) in Industry in 2008 to that in 2009?
Your response must be concise. 1.39. What is the ratio of the Value added (current US$) in Manufacturing in 2008 to that in 2009?
Your answer should be compact. 1.16. What is the ratio of the Value added (current US$) of Services in 2008 to that in 2009?
Your answer should be compact. 1.09. What is the ratio of the Value added (current US$) in Agriculture in 2008 to that in 2009?
Offer a terse response. 0.99. What is the ratio of the Value added (current US$) in Industry in 2008 to that in 2010?
Give a very brief answer. 1.17. What is the ratio of the Value added (current US$) of Manufacturing in 2008 to that in 2010?
Your answer should be compact. 1.05. What is the ratio of the Value added (current US$) in Services in 2008 to that in 2010?
Offer a terse response. 1.03. What is the ratio of the Value added (current US$) of Agriculture in 2008 to that in 2010?
Offer a very short reply. 1.07. What is the ratio of the Value added (current US$) of Industry in 2008 to that in 2011?
Your answer should be compact. 0.87. What is the ratio of the Value added (current US$) of Manufacturing in 2008 to that in 2011?
Provide a succinct answer. 0.89. What is the ratio of the Value added (current US$) of Agriculture in 2008 to that in 2011?
Offer a terse response. 1.02. What is the ratio of the Value added (current US$) of Industry in 2008 to that in 2012?
Your answer should be very brief. 0.82. What is the ratio of the Value added (current US$) in Manufacturing in 2008 to that in 2012?
Your answer should be very brief. 0.82. What is the ratio of the Value added (current US$) in Services in 2008 to that in 2012?
Your response must be concise. 0.88. What is the ratio of the Value added (current US$) in Agriculture in 2008 to that in 2012?
Make the answer very short. 1.01. What is the ratio of the Value added (current US$) in Industry in 2008 to that in 2013?
Offer a terse response. 0.82. What is the ratio of the Value added (current US$) of Manufacturing in 2008 to that in 2013?
Ensure brevity in your answer.  0.79. What is the ratio of the Value added (current US$) of Services in 2008 to that in 2013?
Offer a very short reply. 0.8. What is the ratio of the Value added (current US$) of Agriculture in 2008 to that in 2013?
Keep it short and to the point. 0.99. What is the ratio of the Value added (current US$) in Industry in 2009 to that in 2010?
Offer a very short reply. 0.84. What is the ratio of the Value added (current US$) of Manufacturing in 2009 to that in 2010?
Provide a short and direct response. 0.91. What is the ratio of the Value added (current US$) in Services in 2009 to that in 2010?
Give a very brief answer. 0.94. What is the ratio of the Value added (current US$) of Agriculture in 2009 to that in 2010?
Your answer should be very brief. 1.07. What is the ratio of the Value added (current US$) in Industry in 2009 to that in 2011?
Provide a succinct answer. 0.63. What is the ratio of the Value added (current US$) of Manufacturing in 2009 to that in 2011?
Your answer should be compact. 0.77. What is the ratio of the Value added (current US$) of Services in 2009 to that in 2011?
Your response must be concise. 0.87. What is the ratio of the Value added (current US$) in Agriculture in 2009 to that in 2011?
Provide a short and direct response. 1.03. What is the ratio of the Value added (current US$) of Industry in 2009 to that in 2012?
Offer a terse response. 0.59. What is the ratio of the Value added (current US$) of Manufacturing in 2009 to that in 2012?
Give a very brief answer. 0.7. What is the ratio of the Value added (current US$) of Services in 2009 to that in 2012?
Provide a succinct answer. 0.8. What is the ratio of the Value added (current US$) of Agriculture in 2009 to that in 2012?
Your answer should be compact. 1.02. What is the ratio of the Value added (current US$) in Industry in 2009 to that in 2013?
Provide a succinct answer. 0.59. What is the ratio of the Value added (current US$) in Manufacturing in 2009 to that in 2013?
Make the answer very short. 0.68. What is the ratio of the Value added (current US$) in Services in 2009 to that in 2013?
Keep it short and to the point. 0.74. What is the ratio of the Value added (current US$) of Agriculture in 2009 to that in 2013?
Your response must be concise. 0.99. What is the ratio of the Value added (current US$) of Industry in 2010 to that in 2011?
Keep it short and to the point. 0.75. What is the ratio of the Value added (current US$) in Manufacturing in 2010 to that in 2011?
Make the answer very short. 0.85. What is the ratio of the Value added (current US$) of Services in 2010 to that in 2011?
Make the answer very short. 0.93. What is the ratio of the Value added (current US$) of Agriculture in 2010 to that in 2011?
Your answer should be very brief. 0.96. What is the ratio of the Value added (current US$) of Industry in 2010 to that in 2012?
Provide a succinct answer. 0.7. What is the ratio of the Value added (current US$) of Manufacturing in 2010 to that in 2012?
Make the answer very short. 0.78. What is the ratio of the Value added (current US$) of Services in 2010 to that in 2012?
Your answer should be very brief. 0.85. What is the ratio of the Value added (current US$) in Agriculture in 2010 to that in 2012?
Make the answer very short. 0.95. What is the ratio of the Value added (current US$) in Industry in 2010 to that in 2013?
Provide a short and direct response. 0.7. What is the ratio of the Value added (current US$) of Manufacturing in 2010 to that in 2013?
Make the answer very short. 0.75. What is the ratio of the Value added (current US$) of Services in 2010 to that in 2013?
Keep it short and to the point. 0.78. What is the ratio of the Value added (current US$) in Agriculture in 2010 to that in 2013?
Give a very brief answer. 0.93. What is the ratio of the Value added (current US$) of Industry in 2011 to that in 2012?
Your answer should be compact. 0.94. What is the ratio of the Value added (current US$) of Manufacturing in 2011 to that in 2012?
Provide a short and direct response. 0.92. What is the ratio of the Value added (current US$) of Services in 2011 to that in 2012?
Offer a terse response. 0.92. What is the ratio of the Value added (current US$) of Agriculture in 2011 to that in 2012?
Give a very brief answer. 0.99. What is the ratio of the Value added (current US$) in Industry in 2011 to that in 2013?
Offer a very short reply. 0.94. What is the ratio of the Value added (current US$) of Manufacturing in 2011 to that in 2013?
Offer a terse response. 0.89. What is the ratio of the Value added (current US$) in Services in 2011 to that in 2013?
Provide a short and direct response. 0.84. What is the ratio of the Value added (current US$) in Agriculture in 2011 to that in 2013?
Offer a very short reply. 0.96. What is the ratio of the Value added (current US$) of Industry in 2012 to that in 2013?
Provide a short and direct response. 1. What is the ratio of the Value added (current US$) of Manufacturing in 2012 to that in 2013?
Offer a very short reply. 0.97. What is the ratio of the Value added (current US$) in Services in 2012 to that in 2013?
Make the answer very short. 0.92. What is the ratio of the Value added (current US$) in Agriculture in 2012 to that in 2013?
Your answer should be compact. 0.98. What is the difference between the highest and the second highest Value added (current US$) in Industry?
Make the answer very short. 2.27e+08. What is the difference between the highest and the second highest Value added (current US$) of Manufacturing?
Your answer should be compact. 1.04e+09. What is the difference between the highest and the second highest Value added (current US$) of Services?
Offer a terse response. 1.35e+1. What is the difference between the highest and the second highest Value added (current US$) of Agriculture?
Your answer should be compact. 1.44e+07. What is the difference between the highest and the lowest Value added (current US$) in Industry?
Your answer should be very brief. 9.10e+1. What is the difference between the highest and the lowest Value added (current US$) in Manufacturing?
Provide a short and direct response. 1.09e+1. What is the difference between the highest and the lowest Value added (current US$) in Services?
Your answer should be very brief. 4.76e+1. What is the difference between the highest and the lowest Value added (current US$) of Agriculture?
Offer a terse response. 1.95e+08. 